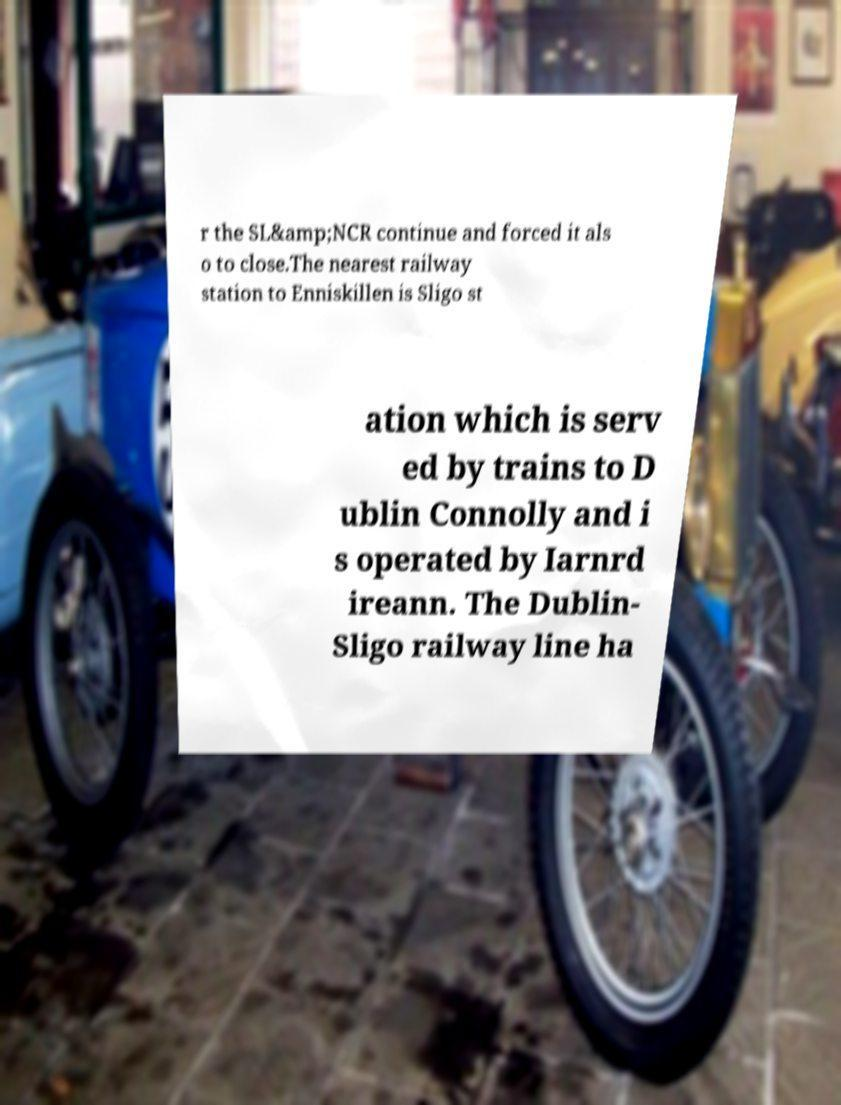For documentation purposes, I need the text within this image transcribed. Could you provide that? r the SL&amp;NCR continue and forced it als o to close.The nearest railway station to Enniskillen is Sligo st ation which is serv ed by trains to D ublin Connolly and i s operated by Iarnrd ireann. The Dublin- Sligo railway line ha 